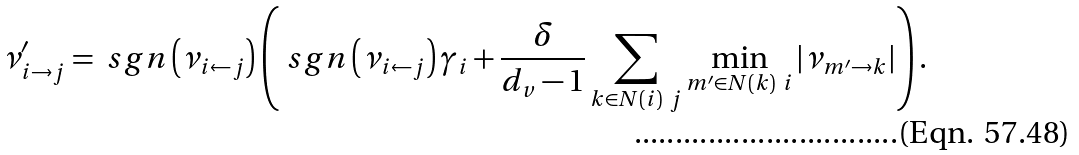Convert formula to latex. <formula><loc_0><loc_0><loc_500><loc_500>\nu _ { i \rightarrow j } ^ { \prime } & = \ s g n \left ( \nu _ { i \leftarrow j } \right ) \left ( \ s g n \left ( \nu _ { i \leftarrow j } \right ) \gamma _ { i } + \frac { \delta } { d _ { v } - 1 } \sum _ { k \in N ( i ) \ j } \min _ { m ^ { \prime } \in N ( k ) \ i } \left | \nu _ { m ^ { \prime } \rightarrow k } \right | \right ) .</formula> 